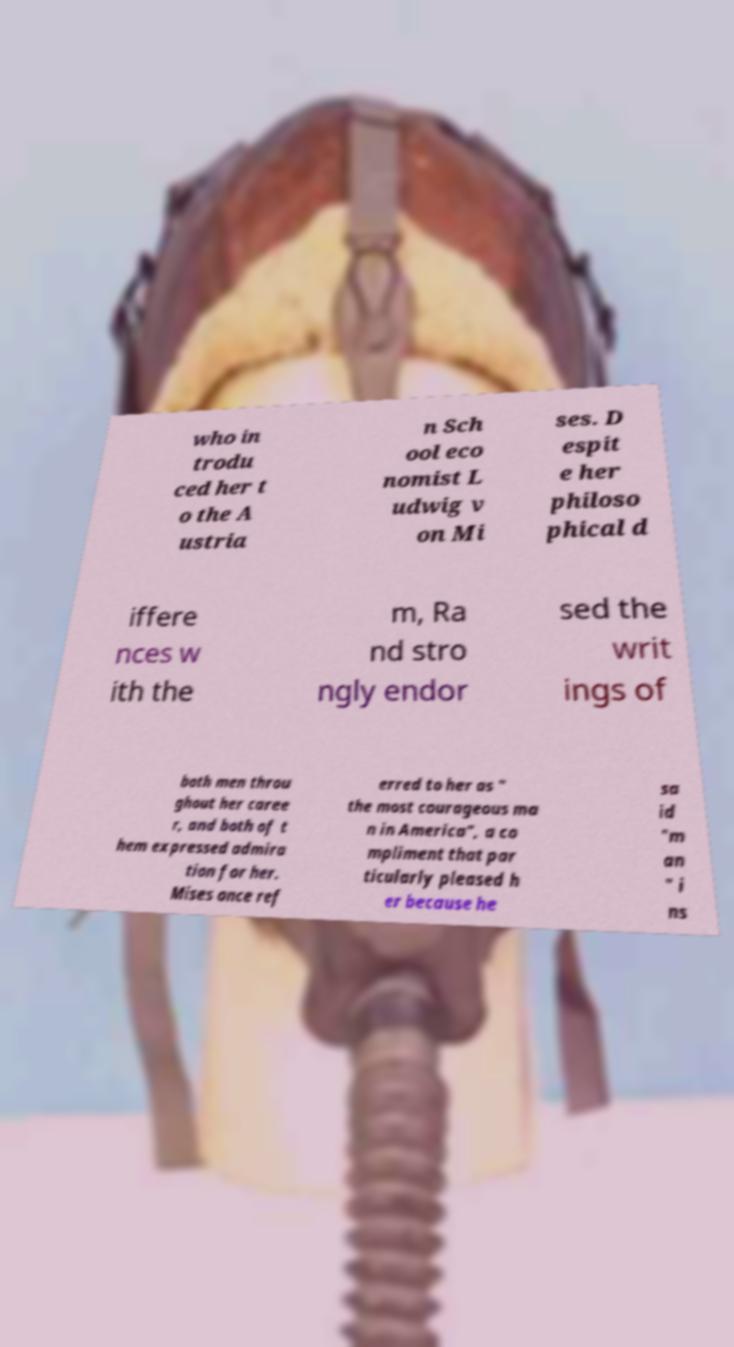What messages or text are displayed in this image? I need them in a readable, typed format. who in trodu ced her t o the A ustria n Sch ool eco nomist L udwig v on Mi ses. D espit e her philoso phical d iffere nces w ith the m, Ra nd stro ngly endor sed the writ ings of both men throu ghout her caree r, and both of t hem expressed admira tion for her. Mises once ref erred to her as " the most courageous ma n in America", a co mpliment that par ticularly pleased h er because he sa id "m an " i ns 